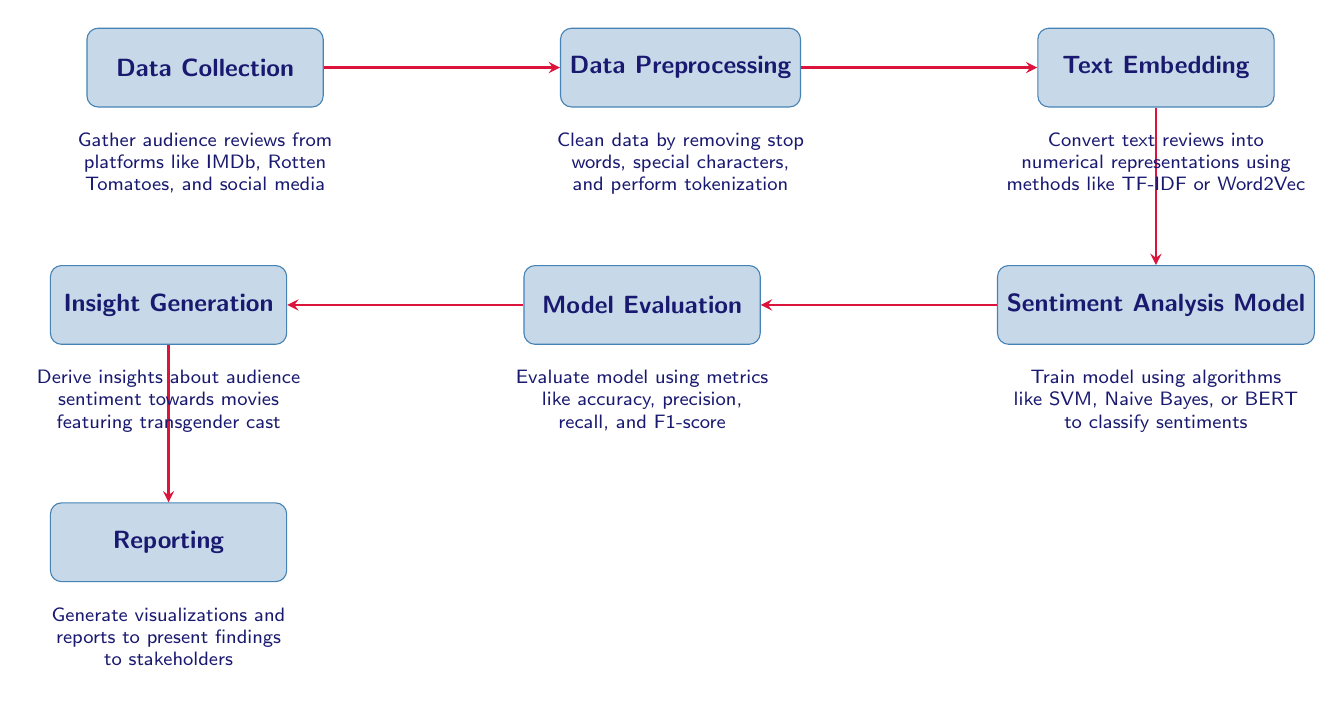What is the first step in the process? The diagram shows that the first step is "Data Collection." This information is located in the far left node, which initiates the flow of the process.
Answer: Data Collection How many nodes are present in the diagram? To determine the number of nodes, we count the distinct processes represented in the diagram: Data Collection, Data Preprocessing, Text Embedding, Sentiment Analysis Model, Model Evaluation, Insight Generation, and Reporting. This totals to seven nodes.
Answer: 7 What is the output of the "Sentiment Analysis Model"? The output of the "Sentiment Analysis Model" flows into the next node, "Model Evaluation." From the diagram, it's clear that the purpose of this model is to classify sentiments from audience reviews.
Answer: Model Evaluation What follows after "Insight Generation"? Moving through the arrows in the diagram, we see that the step following "Insight Generation" is "Reporting." This indicates that insights are summarized and visualized in the reporting phase.
Answer: Reporting Which node directly precedes "Text Embedding"? Following the arrows in the diagram, the node directly preceding "Text Embedding" is "Data Preprocessing." This indicates that preprocessing occurs before embedding text.
Answer: Data Preprocessing What method is suggested for converting text reviews? The diagram notes that text reviews are to be converted into numerical representations using methods mentioned in the node "Text Embedding," specifically TF-IDF or Word2Vec.
Answer: TF-IDF or Word2Vec What is the purpose of "Model Evaluation"? The purpose of "Model Evaluation" is to assess the performance of the sentiment analysis model using metrics such as accuracy, precision, recall, and F1-score, which are explicitly stated in the node.
Answer: Assess performance How does data flow from "Data Collection" to "Text Embedding"? The flow of data starts at "Data Collection," which leads to "Data Preprocessing." From there, preprocessed data flows into "Text Embedding," forming a sequential order of operations.
Answer: Data Preprocessing What insight is generated by the process involving transgender cast movies? The diagram shows that the main goal of the process is to derive insights about audience sentiment specifically towards movies featuring a transgender cast, as stated in the "Insight Generation" node.
Answer: Audience sentiment 